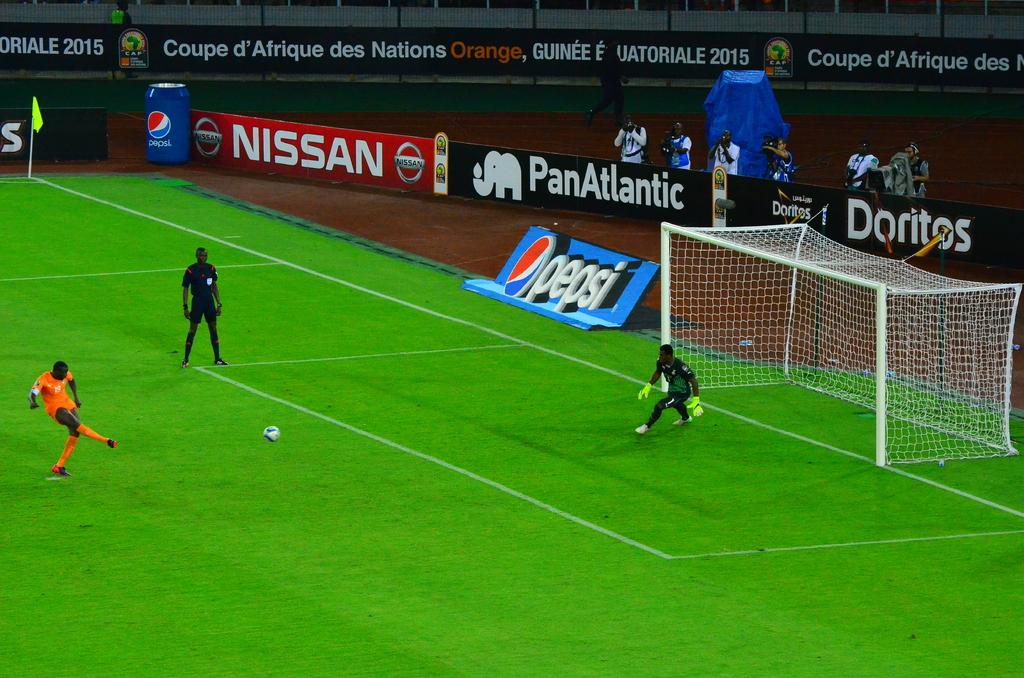What is the drink company in blue next to the goal?
Your answer should be compact. Pepsi. What brand of automobile is advertised?
Give a very brief answer. Nissan. 